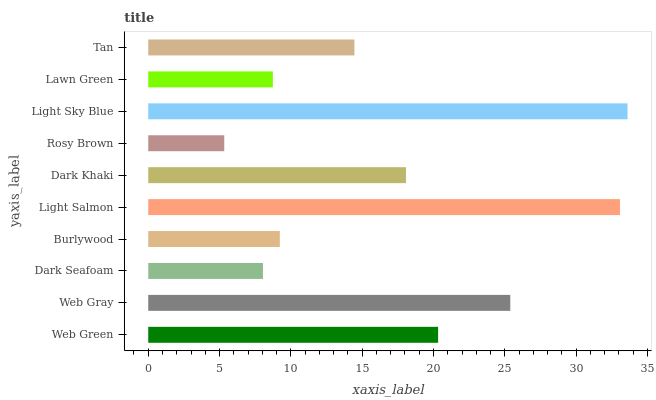Is Rosy Brown the minimum?
Answer yes or no. Yes. Is Light Sky Blue the maximum?
Answer yes or no. Yes. Is Web Gray the minimum?
Answer yes or no. No. Is Web Gray the maximum?
Answer yes or no. No. Is Web Gray greater than Web Green?
Answer yes or no. Yes. Is Web Green less than Web Gray?
Answer yes or no. Yes. Is Web Green greater than Web Gray?
Answer yes or no. No. Is Web Gray less than Web Green?
Answer yes or no. No. Is Dark Khaki the high median?
Answer yes or no. Yes. Is Tan the low median?
Answer yes or no. Yes. Is Web Green the high median?
Answer yes or no. No. Is Burlywood the low median?
Answer yes or no. No. 